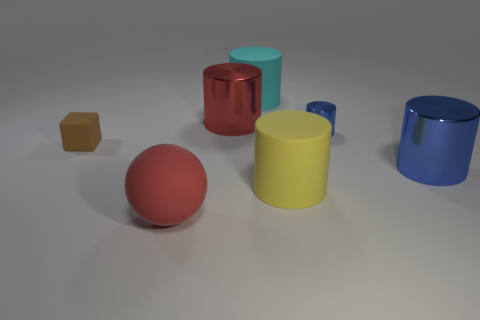Subtract 1 cylinders. How many cylinders are left? 4 Subtract all cyan cylinders. How many cylinders are left? 4 Subtract all cyan cylinders. How many cylinders are left? 4 Subtract all brown cylinders. Subtract all gray cubes. How many cylinders are left? 5 Add 3 yellow balls. How many objects exist? 10 Subtract all blocks. How many objects are left? 6 Subtract 0 brown cylinders. How many objects are left? 7 Subtract all large green rubber cubes. Subtract all large blue objects. How many objects are left? 6 Add 2 cyan cylinders. How many cyan cylinders are left? 3 Add 4 tiny cylinders. How many tiny cylinders exist? 5 